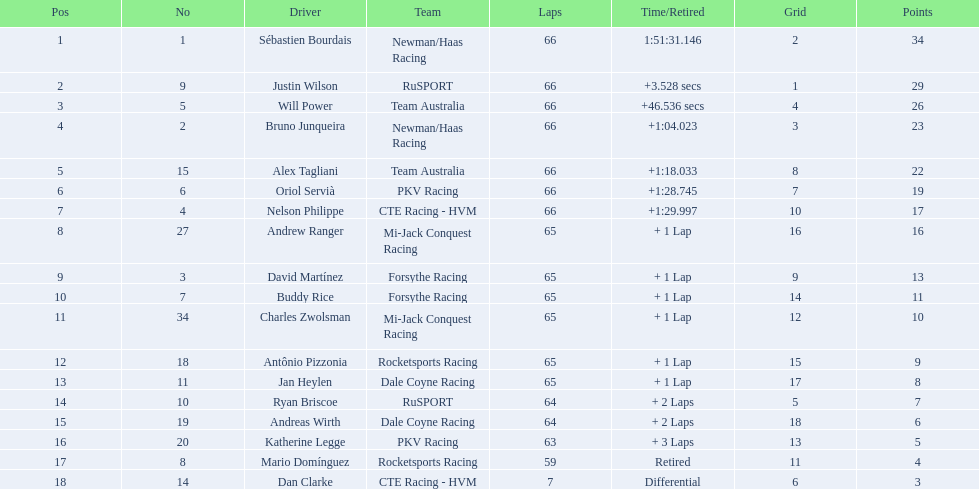Who are the drivers with 10 or more points? Sébastien Bourdais, Justin Wilson, Will Power, Bruno Junqueira, Alex Tagliani, Oriol Servià, Nelson Philippe, Andrew Ranger, David Martínez, Buddy Rice, Charles Zwolsman. From that group, who scored 20 points or more? Sébastien Bourdais, Justin Wilson, Will Power, Bruno Junqueira, Alex Tagliani. Among the top 5, who earned the most points? Sébastien Bourdais. 